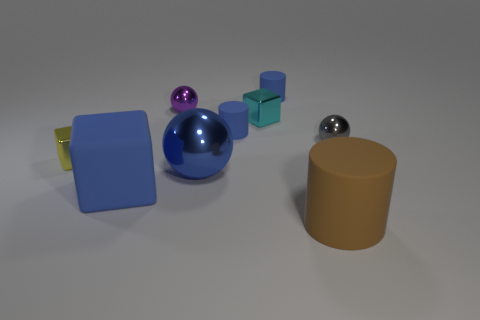The metallic sphere that is the same color as the rubber cube is what size?
Give a very brief answer. Large. What number of other objects are there of the same shape as the small gray object?
Ensure brevity in your answer.  2. What shape is the small shiny thing that is in front of the shiny object on the right side of the large rubber object that is on the right side of the large sphere?
Ensure brevity in your answer.  Cube. What number of objects are either tiny cyan objects or small metal cubes on the right side of the tiny yellow shiny cube?
Your answer should be very brief. 1. There is a small blue object that is to the left of the small cyan shiny block; is it the same shape as the thing that is to the right of the big brown matte thing?
Your response must be concise. No. How many objects are big rubber objects or blocks?
Your response must be concise. 4. Is there a small red cylinder?
Ensure brevity in your answer.  No. Are the small ball right of the large cylinder and the big blue block made of the same material?
Offer a terse response. No. Is there a cyan metal object that has the same shape as the big blue metallic thing?
Keep it short and to the point. No. Is the number of blue cylinders that are on the left side of the blue metal sphere the same as the number of small yellow shiny objects?
Your answer should be compact. No. 